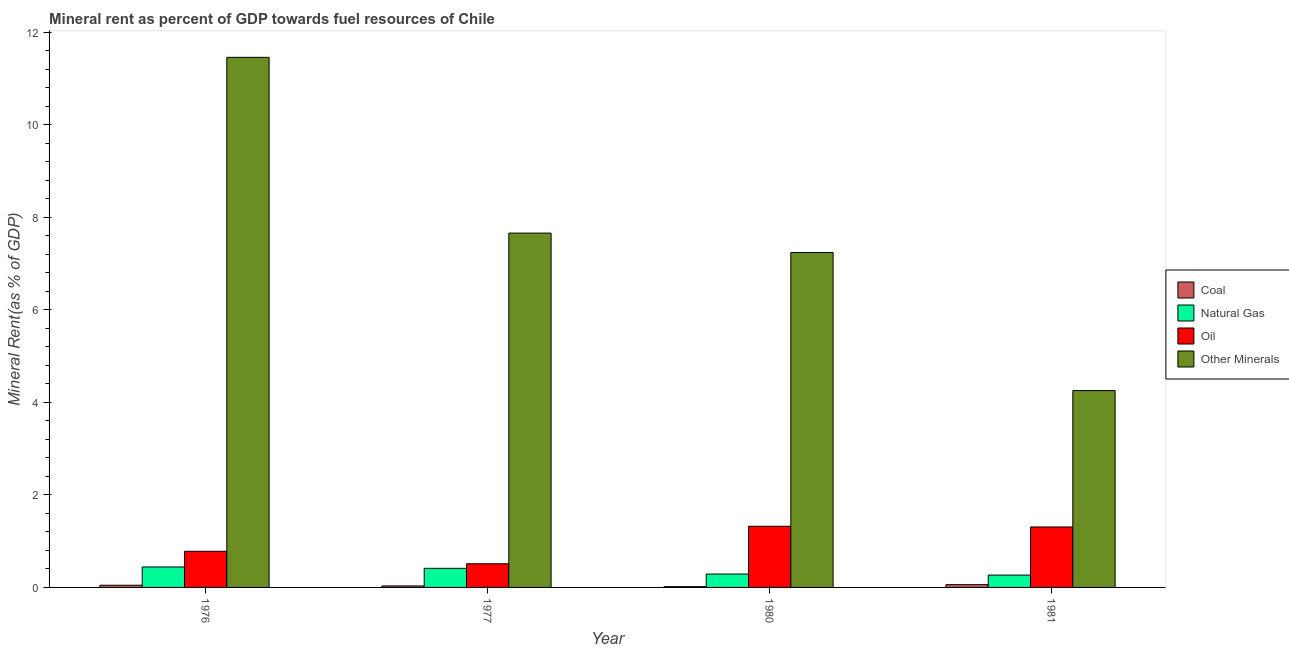How many groups of bars are there?
Your response must be concise. 4. Are the number of bars on each tick of the X-axis equal?
Ensure brevity in your answer.  Yes. How many bars are there on the 3rd tick from the left?
Your response must be concise. 4. In how many cases, is the number of bars for a given year not equal to the number of legend labels?
Make the answer very short. 0. What is the coal rent in 1977?
Offer a terse response. 0.03. Across all years, what is the maximum  rent of other minerals?
Keep it short and to the point. 11.46. Across all years, what is the minimum coal rent?
Make the answer very short. 0.02. In which year was the natural gas rent maximum?
Your answer should be compact. 1976. What is the total oil rent in the graph?
Make the answer very short. 3.92. What is the difference between the oil rent in 1976 and that in 1981?
Your answer should be compact. -0.53. What is the difference between the oil rent in 1977 and the natural gas rent in 1980?
Offer a terse response. -0.81. What is the average oil rent per year?
Your answer should be very brief. 0.98. What is the ratio of the oil rent in 1976 to that in 1980?
Your answer should be compact. 0.59. Is the coal rent in 1976 less than that in 1980?
Keep it short and to the point. No. Is the difference between the natural gas rent in 1977 and 1980 greater than the difference between the coal rent in 1977 and 1980?
Give a very brief answer. No. What is the difference between the highest and the second highest natural gas rent?
Offer a very short reply. 0.03. What is the difference between the highest and the lowest coal rent?
Your answer should be very brief. 0.04. Is it the case that in every year, the sum of the natural gas rent and  rent of other minerals is greater than the sum of oil rent and coal rent?
Provide a short and direct response. No. What does the 2nd bar from the left in 1976 represents?
Provide a succinct answer. Natural Gas. What does the 3rd bar from the right in 1980 represents?
Give a very brief answer. Natural Gas. How many years are there in the graph?
Your answer should be very brief. 4. What is the difference between two consecutive major ticks on the Y-axis?
Ensure brevity in your answer.  2. Are the values on the major ticks of Y-axis written in scientific E-notation?
Offer a terse response. No. Does the graph contain grids?
Make the answer very short. No. What is the title of the graph?
Offer a terse response. Mineral rent as percent of GDP towards fuel resources of Chile. Does "Secondary general education" appear as one of the legend labels in the graph?
Your answer should be compact. No. What is the label or title of the X-axis?
Your answer should be compact. Year. What is the label or title of the Y-axis?
Your answer should be compact. Mineral Rent(as % of GDP). What is the Mineral Rent(as % of GDP) of Coal in 1976?
Offer a very short reply. 0.05. What is the Mineral Rent(as % of GDP) in Natural Gas in 1976?
Your answer should be compact. 0.44. What is the Mineral Rent(as % of GDP) in Oil in 1976?
Make the answer very short. 0.78. What is the Mineral Rent(as % of GDP) of Other Minerals in 1976?
Make the answer very short. 11.46. What is the Mineral Rent(as % of GDP) in Coal in 1977?
Your answer should be very brief. 0.03. What is the Mineral Rent(as % of GDP) in Natural Gas in 1977?
Make the answer very short. 0.41. What is the Mineral Rent(as % of GDP) in Oil in 1977?
Your response must be concise. 0.51. What is the Mineral Rent(as % of GDP) in Other Minerals in 1977?
Make the answer very short. 7.66. What is the Mineral Rent(as % of GDP) of Coal in 1980?
Keep it short and to the point. 0.02. What is the Mineral Rent(as % of GDP) of Natural Gas in 1980?
Ensure brevity in your answer.  0.29. What is the Mineral Rent(as % of GDP) in Oil in 1980?
Ensure brevity in your answer.  1.32. What is the Mineral Rent(as % of GDP) of Other Minerals in 1980?
Offer a terse response. 7.24. What is the Mineral Rent(as % of GDP) in Coal in 1981?
Your answer should be very brief. 0.06. What is the Mineral Rent(as % of GDP) in Natural Gas in 1981?
Make the answer very short. 0.27. What is the Mineral Rent(as % of GDP) of Oil in 1981?
Keep it short and to the point. 1.31. What is the Mineral Rent(as % of GDP) of Other Minerals in 1981?
Provide a succinct answer. 4.25. Across all years, what is the maximum Mineral Rent(as % of GDP) of Coal?
Give a very brief answer. 0.06. Across all years, what is the maximum Mineral Rent(as % of GDP) in Natural Gas?
Provide a short and direct response. 0.44. Across all years, what is the maximum Mineral Rent(as % of GDP) of Oil?
Make the answer very short. 1.32. Across all years, what is the maximum Mineral Rent(as % of GDP) in Other Minerals?
Make the answer very short. 11.46. Across all years, what is the minimum Mineral Rent(as % of GDP) in Coal?
Your answer should be very brief. 0.02. Across all years, what is the minimum Mineral Rent(as % of GDP) of Natural Gas?
Your answer should be compact. 0.27. Across all years, what is the minimum Mineral Rent(as % of GDP) in Oil?
Your response must be concise. 0.51. Across all years, what is the minimum Mineral Rent(as % of GDP) of Other Minerals?
Provide a short and direct response. 4.25. What is the total Mineral Rent(as % of GDP) in Coal in the graph?
Ensure brevity in your answer.  0.16. What is the total Mineral Rent(as % of GDP) in Natural Gas in the graph?
Offer a very short reply. 1.41. What is the total Mineral Rent(as % of GDP) of Oil in the graph?
Provide a succinct answer. 3.92. What is the total Mineral Rent(as % of GDP) in Other Minerals in the graph?
Provide a short and direct response. 30.6. What is the difference between the Mineral Rent(as % of GDP) in Coal in 1976 and that in 1977?
Make the answer very short. 0.01. What is the difference between the Mineral Rent(as % of GDP) in Natural Gas in 1976 and that in 1977?
Provide a succinct answer. 0.03. What is the difference between the Mineral Rent(as % of GDP) in Oil in 1976 and that in 1977?
Your response must be concise. 0.27. What is the difference between the Mineral Rent(as % of GDP) in Other Minerals in 1976 and that in 1977?
Provide a short and direct response. 3.8. What is the difference between the Mineral Rent(as % of GDP) in Coal in 1976 and that in 1980?
Keep it short and to the point. 0.03. What is the difference between the Mineral Rent(as % of GDP) in Natural Gas in 1976 and that in 1980?
Ensure brevity in your answer.  0.15. What is the difference between the Mineral Rent(as % of GDP) in Oil in 1976 and that in 1980?
Provide a succinct answer. -0.54. What is the difference between the Mineral Rent(as % of GDP) in Other Minerals in 1976 and that in 1980?
Your answer should be compact. 4.22. What is the difference between the Mineral Rent(as % of GDP) of Coal in 1976 and that in 1981?
Provide a succinct answer. -0.01. What is the difference between the Mineral Rent(as % of GDP) of Natural Gas in 1976 and that in 1981?
Your response must be concise. 0.18. What is the difference between the Mineral Rent(as % of GDP) of Oil in 1976 and that in 1981?
Provide a succinct answer. -0.53. What is the difference between the Mineral Rent(as % of GDP) in Other Minerals in 1976 and that in 1981?
Keep it short and to the point. 7.2. What is the difference between the Mineral Rent(as % of GDP) of Coal in 1977 and that in 1980?
Make the answer very short. 0.02. What is the difference between the Mineral Rent(as % of GDP) of Natural Gas in 1977 and that in 1980?
Make the answer very short. 0.12. What is the difference between the Mineral Rent(as % of GDP) of Oil in 1977 and that in 1980?
Provide a succinct answer. -0.81. What is the difference between the Mineral Rent(as % of GDP) in Other Minerals in 1977 and that in 1980?
Your response must be concise. 0.42. What is the difference between the Mineral Rent(as % of GDP) in Coal in 1977 and that in 1981?
Make the answer very short. -0.03. What is the difference between the Mineral Rent(as % of GDP) of Natural Gas in 1977 and that in 1981?
Make the answer very short. 0.15. What is the difference between the Mineral Rent(as % of GDP) in Oil in 1977 and that in 1981?
Give a very brief answer. -0.8. What is the difference between the Mineral Rent(as % of GDP) of Other Minerals in 1977 and that in 1981?
Your answer should be very brief. 3.4. What is the difference between the Mineral Rent(as % of GDP) of Coal in 1980 and that in 1981?
Provide a short and direct response. -0.04. What is the difference between the Mineral Rent(as % of GDP) in Natural Gas in 1980 and that in 1981?
Provide a short and direct response. 0.02. What is the difference between the Mineral Rent(as % of GDP) in Oil in 1980 and that in 1981?
Your answer should be very brief. 0.02. What is the difference between the Mineral Rent(as % of GDP) of Other Minerals in 1980 and that in 1981?
Your answer should be very brief. 2.98. What is the difference between the Mineral Rent(as % of GDP) in Coal in 1976 and the Mineral Rent(as % of GDP) in Natural Gas in 1977?
Make the answer very short. -0.37. What is the difference between the Mineral Rent(as % of GDP) of Coal in 1976 and the Mineral Rent(as % of GDP) of Oil in 1977?
Make the answer very short. -0.46. What is the difference between the Mineral Rent(as % of GDP) in Coal in 1976 and the Mineral Rent(as % of GDP) in Other Minerals in 1977?
Make the answer very short. -7.61. What is the difference between the Mineral Rent(as % of GDP) in Natural Gas in 1976 and the Mineral Rent(as % of GDP) in Oil in 1977?
Ensure brevity in your answer.  -0.07. What is the difference between the Mineral Rent(as % of GDP) of Natural Gas in 1976 and the Mineral Rent(as % of GDP) of Other Minerals in 1977?
Your answer should be compact. -7.22. What is the difference between the Mineral Rent(as % of GDP) of Oil in 1976 and the Mineral Rent(as % of GDP) of Other Minerals in 1977?
Offer a very short reply. -6.88. What is the difference between the Mineral Rent(as % of GDP) in Coal in 1976 and the Mineral Rent(as % of GDP) in Natural Gas in 1980?
Your response must be concise. -0.24. What is the difference between the Mineral Rent(as % of GDP) in Coal in 1976 and the Mineral Rent(as % of GDP) in Oil in 1980?
Provide a short and direct response. -1.27. What is the difference between the Mineral Rent(as % of GDP) of Coal in 1976 and the Mineral Rent(as % of GDP) of Other Minerals in 1980?
Offer a terse response. -7.19. What is the difference between the Mineral Rent(as % of GDP) of Natural Gas in 1976 and the Mineral Rent(as % of GDP) of Oil in 1980?
Ensure brevity in your answer.  -0.88. What is the difference between the Mineral Rent(as % of GDP) in Natural Gas in 1976 and the Mineral Rent(as % of GDP) in Other Minerals in 1980?
Offer a terse response. -6.8. What is the difference between the Mineral Rent(as % of GDP) of Oil in 1976 and the Mineral Rent(as % of GDP) of Other Minerals in 1980?
Ensure brevity in your answer.  -6.46. What is the difference between the Mineral Rent(as % of GDP) of Coal in 1976 and the Mineral Rent(as % of GDP) of Natural Gas in 1981?
Your response must be concise. -0.22. What is the difference between the Mineral Rent(as % of GDP) in Coal in 1976 and the Mineral Rent(as % of GDP) in Oil in 1981?
Offer a terse response. -1.26. What is the difference between the Mineral Rent(as % of GDP) in Coal in 1976 and the Mineral Rent(as % of GDP) in Other Minerals in 1981?
Offer a very short reply. -4.21. What is the difference between the Mineral Rent(as % of GDP) in Natural Gas in 1976 and the Mineral Rent(as % of GDP) in Oil in 1981?
Offer a very short reply. -0.86. What is the difference between the Mineral Rent(as % of GDP) of Natural Gas in 1976 and the Mineral Rent(as % of GDP) of Other Minerals in 1981?
Your response must be concise. -3.81. What is the difference between the Mineral Rent(as % of GDP) of Oil in 1976 and the Mineral Rent(as % of GDP) of Other Minerals in 1981?
Offer a terse response. -3.47. What is the difference between the Mineral Rent(as % of GDP) of Coal in 1977 and the Mineral Rent(as % of GDP) of Natural Gas in 1980?
Provide a short and direct response. -0.26. What is the difference between the Mineral Rent(as % of GDP) of Coal in 1977 and the Mineral Rent(as % of GDP) of Oil in 1980?
Your response must be concise. -1.29. What is the difference between the Mineral Rent(as % of GDP) of Coal in 1977 and the Mineral Rent(as % of GDP) of Other Minerals in 1980?
Provide a short and direct response. -7.2. What is the difference between the Mineral Rent(as % of GDP) in Natural Gas in 1977 and the Mineral Rent(as % of GDP) in Oil in 1980?
Offer a terse response. -0.91. What is the difference between the Mineral Rent(as % of GDP) in Natural Gas in 1977 and the Mineral Rent(as % of GDP) in Other Minerals in 1980?
Provide a short and direct response. -6.82. What is the difference between the Mineral Rent(as % of GDP) in Oil in 1977 and the Mineral Rent(as % of GDP) in Other Minerals in 1980?
Your response must be concise. -6.73. What is the difference between the Mineral Rent(as % of GDP) of Coal in 1977 and the Mineral Rent(as % of GDP) of Natural Gas in 1981?
Offer a very short reply. -0.23. What is the difference between the Mineral Rent(as % of GDP) of Coal in 1977 and the Mineral Rent(as % of GDP) of Oil in 1981?
Offer a terse response. -1.27. What is the difference between the Mineral Rent(as % of GDP) in Coal in 1977 and the Mineral Rent(as % of GDP) in Other Minerals in 1981?
Offer a very short reply. -4.22. What is the difference between the Mineral Rent(as % of GDP) of Natural Gas in 1977 and the Mineral Rent(as % of GDP) of Oil in 1981?
Give a very brief answer. -0.89. What is the difference between the Mineral Rent(as % of GDP) of Natural Gas in 1977 and the Mineral Rent(as % of GDP) of Other Minerals in 1981?
Offer a very short reply. -3.84. What is the difference between the Mineral Rent(as % of GDP) of Oil in 1977 and the Mineral Rent(as % of GDP) of Other Minerals in 1981?
Offer a terse response. -3.74. What is the difference between the Mineral Rent(as % of GDP) in Coal in 1980 and the Mineral Rent(as % of GDP) in Natural Gas in 1981?
Provide a succinct answer. -0.25. What is the difference between the Mineral Rent(as % of GDP) of Coal in 1980 and the Mineral Rent(as % of GDP) of Oil in 1981?
Give a very brief answer. -1.29. What is the difference between the Mineral Rent(as % of GDP) of Coal in 1980 and the Mineral Rent(as % of GDP) of Other Minerals in 1981?
Your answer should be compact. -4.24. What is the difference between the Mineral Rent(as % of GDP) in Natural Gas in 1980 and the Mineral Rent(as % of GDP) in Oil in 1981?
Provide a succinct answer. -1.02. What is the difference between the Mineral Rent(as % of GDP) of Natural Gas in 1980 and the Mineral Rent(as % of GDP) of Other Minerals in 1981?
Offer a very short reply. -3.96. What is the difference between the Mineral Rent(as % of GDP) in Oil in 1980 and the Mineral Rent(as % of GDP) in Other Minerals in 1981?
Your response must be concise. -2.93. What is the average Mineral Rent(as % of GDP) of Coal per year?
Offer a very short reply. 0.04. What is the average Mineral Rent(as % of GDP) in Natural Gas per year?
Keep it short and to the point. 0.35. What is the average Mineral Rent(as % of GDP) in Oil per year?
Your answer should be very brief. 0.98. What is the average Mineral Rent(as % of GDP) of Other Minerals per year?
Keep it short and to the point. 7.65. In the year 1976, what is the difference between the Mineral Rent(as % of GDP) in Coal and Mineral Rent(as % of GDP) in Natural Gas?
Keep it short and to the point. -0.39. In the year 1976, what is the difference between the Mineral Rent(as % of GDP) in Coal and Mineral Rent(as % of GDP) in Oil?
Provide a succinct answer. -0.73. In the year 1976, what is the difference between the Mineral Rent(as % of GDP) in Coal and Mineral Rent(as % of GDP) in Other Minerals?
Provide a succinct answer. -11.41. In the year 1976, what is the difference between the Mineral Rent(as % of GDP) of Natural Gas and Mineral Rent(as % of GDP) of Oil?
Keep it short and to the point. -0.34. In the year 1976, what is the difference between the Mineral Rent(as % of GDP) of Natural Gas and Mineral Rent(as % of GDP) of Other Minerals?
Provide a short and direct response. -11.01. In the year 1976, what is the difference between the Mineral Rent(as % of GDP) of Oil and Mineral Rent(as % of GDP) of Other Minerals?
Offer a terse response. -10.67. In the year 1977, what is the difference between the Mineral Rent(as % of GDP) of Coal and Mineral Rent(as % of GDP) of Natural Gas?
Offer a very short reply. -0.38. In the year 1977, what is the difference between the Mineral Rent(as % of GDP) of Coal and Mineral Rent(as % of GDP) of Oil?
Give a very brief answer. -0.48. In the year 1977, what is the difference between the Mineral Rent(as % of GDP) in Coal and Mineral Rent(as % of GDP) in Other Minerals?
Give a very brief answer. -7.63. In the year 1977, what is the difference between the Mineral Rent(as % of GDP) of Natural Gas and Mineral Rent(as % of GDP) of Oil?
Ensure brevity in your answer.  -0.1. In the year 1977, what is the difference between the Mineral Rent(as % of GDP) of Natural Gas and Mineral Rent(as % of GDP) of Other Minerals?
Provide a short and direct response. -7.25. In the year 1977, what is the difference between the Mineral Rent(as % of GDP) of Oil and Mineral Rent(as % of GDP) of Other Minerals?
Offer a very short reply. -7.15. In the year 1980, what is the difference between the Mineral Rent(as % of GDP) of Coal and Mineral Rent(as % of GDP) of Natural Gas?
Your response must be concise. -0.27. In the year 1980, what is the difference between the Mineral Rent(as % of GDP) in Coal and Mineral Rent(as % of GDP) in Oil?
Provide a short and direct response. -1.31. In the year 1980, what is the difference between the Mineral Rent(as % of GDP) in Coal and Mineral Rent(as % of GDP) in Other Minerals?
Keep it short and to the point. -7.22. In the year 1980, what is the difference between the Mineral Rent(as % of GDP) of Natural Gas and Mineral Rent(as % of GDP) of Oil?
Ensure brevity in your answer.  -1.03. In the year 1980, what is the difference between the Mineral Rent(as % of GDP) in Natural Gas and Mineral Rent(as % of GDP) in Other Minerals?
Ensure brevity in your answer.  -6.95. In the year 1980, what is the difference between the Mineral Rent(as % of GDP) in Oil and Mineral Rent(as % of GDP) in Other Minerals?
Provide a short and direct response. -5.92. In the year 1981, what is the difference between the Mineral Rent(as % of GDP) in Coal and Mineral Rent(as % of GDP) in Natural Gas?
Offer a very short reply. -0.21. In the year 1981, what is the difference between the Mineral Rent(as % of GDP) in Coal and Mineral Rent(as % of GDP) in Oil?
Provide a succinct answer. -1.25. In the year 1981, what is the difference between the Mineral Rent(as % of GDP) in Coal and Mineral Rent(as % of GDP) in Other Minerals?
Your response must be concise. -4.19. In the year 1981, what is the difference between the Mineral Rent(as % of GDP) in Natural Gas and Mineral Rent(as % of GDP) in Oil?
Keep it short and to the point. -1.04. In the year 1981, what is the difference between the Mineral Rent(as % of GDP) of Natural Gas and Mineral Rent(as % of GDP) of Other Minerals?
Your response must be concise. -3.99. In the year 1981, what is the difference between the Mineral Rent(as % of GDP) in Oil and Mineral Rent(as % of GDP) in Other Minerals?
Your answer should be compact. -2.95. What is the ratio of the Mineral Rent(as % of GDP) in Coal in 1976 to that in 1977?
Keep it short and to the point. 1.46. What is the ratio of the Mineral Rent(as % of GDP) of Natural Gas in 1976 to that in 1977?
Make the answer very short. 1.07. What is the ratio of the Mineral Rent(as % of GDP) of Oil in 1976 to that in 1977?
Ensure brevity in your answer.  1.53. What is the ratio of the Mineral Rent(as % of GDP) of Other Minerals in 1976 to that in 1977?
Your answer should be very brief. 1.5. What is the ratio of the Mineral Rent(as % of GDP) of Coal in 1976 to that in 1980?
Keep it short and to the point. 2.88. What is the ratio of the Mineral Rent(as % of GDP) in Natural Gas in 1976 to that in 1980?
Provide a short and direct response. 1.53. What is the ratio of the Mineral Rent(as % of GDP) of Oil in 1976 to that in 1980?
Your answer should be compact. 0.59. What is the ratio of the Mineral Rent(as % of GDP) in Other Minerals in 1976 to that in 1980?
Ensure brevity in your answer.  1.58. What is the ratio of the Mineral Rent(as % of GDP) of Coal in 1976 to that in 1981?
Your answer should be very brief. 0.79. What is the ratio of the Mineral Rent(as % of GDP) of Natural Gas in 1976 to that in 1981?
Provide a succinct answer. 1.66. What is the ratio of the Mineral Rent(as % of GDP) of Oil in 1976 to that in 1981?
Keep it short and to the point. 0.6. What is the ratio of the Mineral Rent(as % of GDP) of Other Minerals in 1976 to that in 1981?
Your response must be concise. 2.69. What is the ratio of the Mineral Rent(as % of GDP) of Coal in 1977 to that in 1980?
Ensure brevity in your answer.  1.97. What is the ratio of the Mineral Rent(as % of GDP) of Natural Gas in 1977 to that in 1980?
Your answer should be compact. 1.43. What is the ratio of the Mineral Rent(as % of GDP) of Oil in 1977 to that in 1980?
Provide a short and direct response. 0.39. What is the ratio of the Mineral Rent(as % of GDP) of Other Minerals in 1977 to that in 1980?
Provide a succinct answer. 1.06. What is the ratio of the Mineral Rent(as % of GDP) of Coal in 1977 to that in 1981?
Give a very brief answer. 0.54. What is the ratio of the Mineral Rent(as % of GDP) in Natural Gas in 1977 to that in 1981?
Your answer should be very brief. 1.55. What is the ratio of the Mineral Rent(as % of GDP) of Oil in 1977 to that in 1981?
Offer a terse response. 0.39. What is the ratio of the Mineral Rent(as % of GDP) in Other Minerals in 1977 to that in 1981?
Offer a terse response. 1.8. What is the ratio of the Mineral Rent(as % of GDP) of Coal in 1980 to that in 1981?
Make the answer very short. 0.27. What is the ratio of the Mineral Rent(as % of GDP) in Oil in 1980 to that in 1981?
Ensure brevity in your answer.  1.01. What is the ratio of the Mineral Rent(as % of GDP) of Other Minerals in 1980 to that in 1981?
Give a very brief answer. 1.7. What is the difference between the highest and the second highest Mineral Rent(as % of GDP) of Coal?
Your answer should be compact. 0.01. What is the difference between the highest and the second highest Mineral Rent(as % of GDP) of Natural Gas?
Your answer should be compact. 0.03. What is the difference between the highest and the second highest Mineral Rent(as % of GDP) in Oil?
Give a very brief answer. 0.02. What is the difference between the highest and the second highest Mineral Rent(as % of GDP) in Other Minerals?
Your response must be concise. 3.8. What is the difference between the highest and the lowest Mineral Rent(as % of GDP) of Coal?
Your response must be concise. 0.04. What is the difference between the highest and the lowest Mineral Rent(as % of GDP) of Natural Gas?
Your response must be concise. 0.18. What is the difference between the highest and the lowest Mineral Rent(as % of GDP) in Oil?
Ensure brevity in your answer.  0.81. What is the difference between the highest and the lowest Mineral Rent(as % of GDP) of Other Minerals?
Keep it short and to the point. 7.2. 